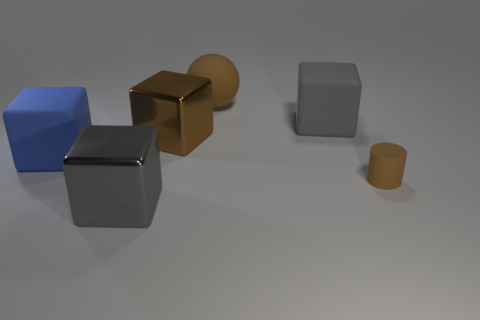What size is the cube that is the same color as the matte cylinder? The cube sharing the same matte finish and color as the cylinder is the smaller one located on the right side of the image. 